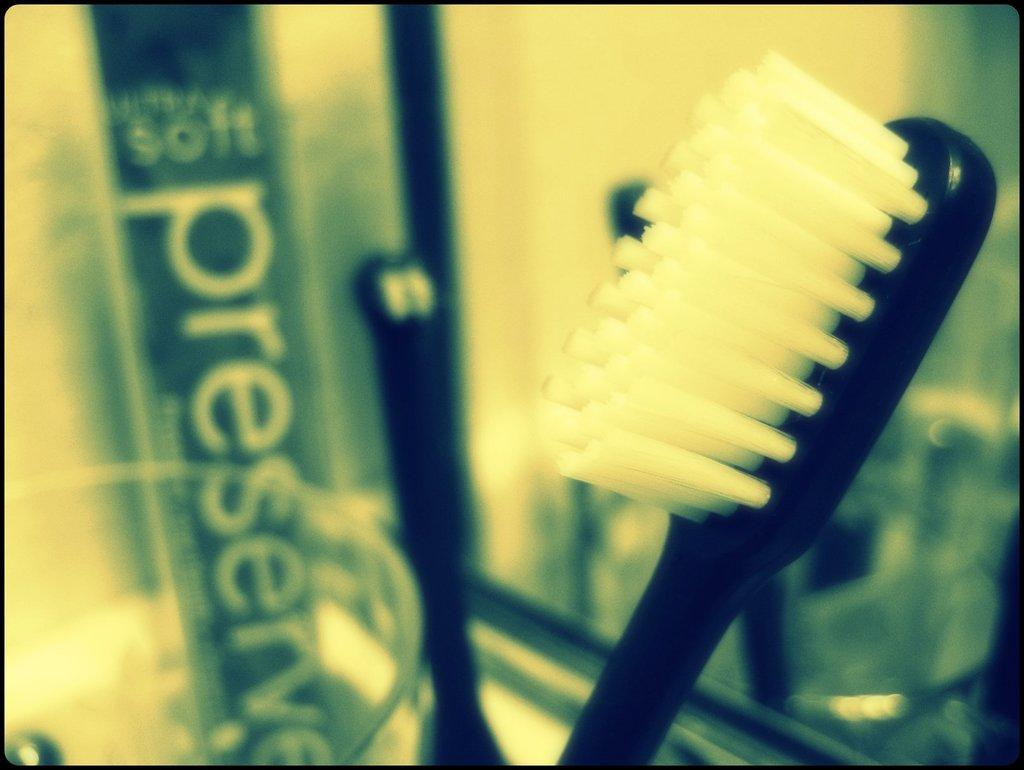What object in the image is typically used for drinking? There is a glass in the image, which is typically used for drinking. What object in the image is used for personal hygiene? There is a toothbrush in the image, which is used for personal hygiene. What object in the image is used for personal grooming? There is a mirror in the image, which is used for personal grooming. What type of silver sponge can be seen in the image? There is no sponge, silver or otherwise, present in the image. What time of day is depicted in the image? The time of day cannot be determined from the image, as there are no clues to suggest whether it is day or night. 